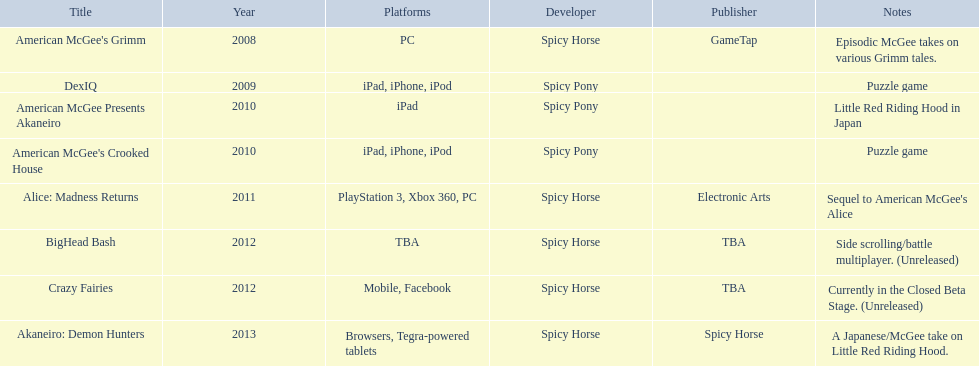What are all of the titles? American McGee's Grimm, DexIQ, American McGee Presents Akaneiro, American McGee's Crooked House, Alice: Madness Returns, BigHead Bash, Crazy Fairies, Akaneiro: Demon Hunters. Who published each title? GameTap, , , , Electronic Arts, TBA, TBA, Spicy Horse. Which game was published by electronics arts? Alice: Madness Returns. Which spicy horse games are displayed? American McGee's Grimm, DexIQ, American McGee Presents Akaneiro, American McGee's Crooked House, Alice: Madness Returns, BigHead Bash, Crazy Fairies, Akaneiro: Demon Hunters. Among them, which ones are available for the ipad? DexIQ, American McGee Presents Akaneiro, American McGee's Crooked House. Which of these are not compatible with the iphone or ipod? American McGee Presents Akaneiro. 